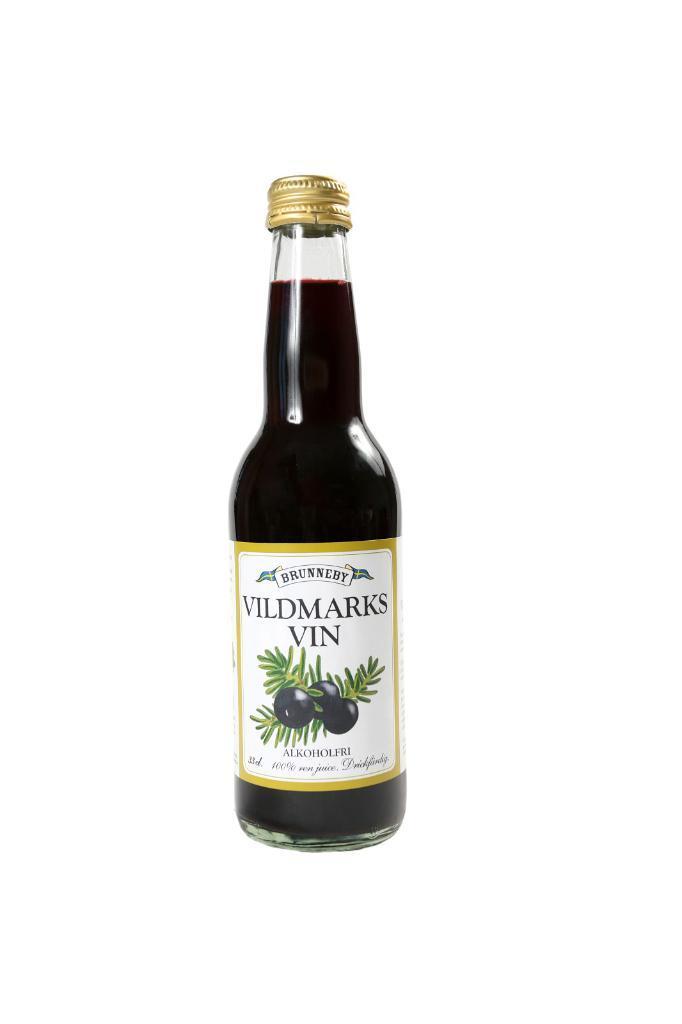Can you describe this image briefly? There is a bottle with some liquid filled in it in this picture. In the background there is white. 